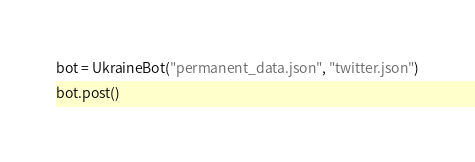<code> <loc_0><loc_0><loc_500><loc_500><_Python_>
bot = UkraineBot("permanent_data.json", "twitter.json")
bot.post()</code> 